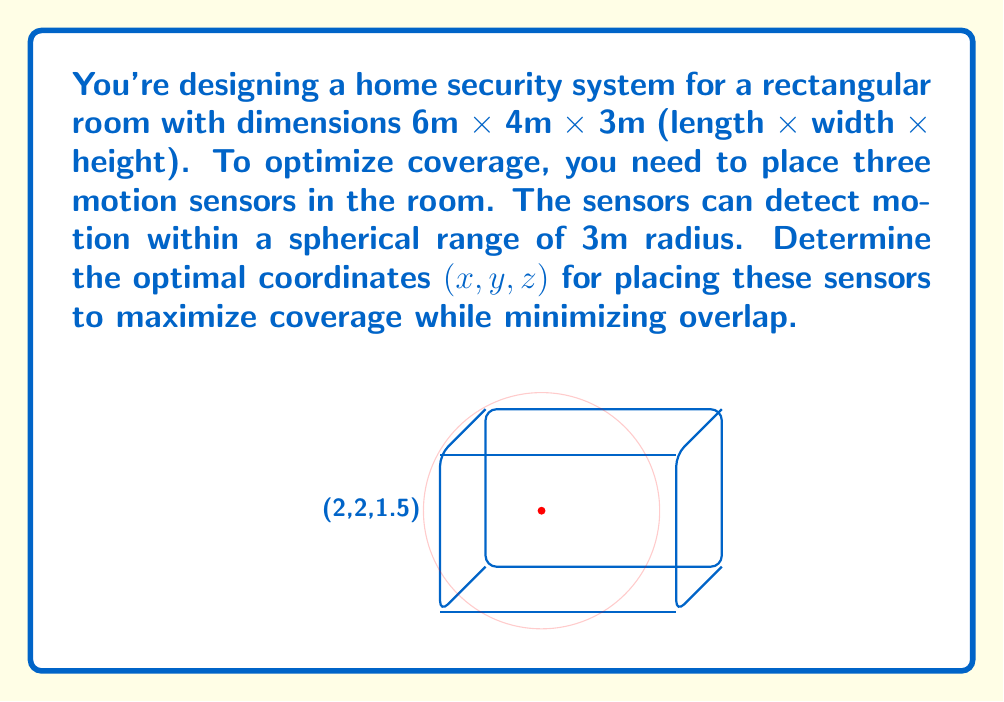Teach me how to tackle this problem. Let's approach this step-by-step:

1) First, we need to consider the room's dimensions and the sensors' range:
   Room: 6m x 4m x 3m
   Sensor range: 3m radius

2) To maximize coverage and minimize overlap, we should place the sensors as far apart as possible while still covering the entire room.

3) Given the room's dimensions, we can place the sensors at the following coordinates:
   Sensor 1: $$(x_1, y_1, z_1) = (2, 2, 1.5)$$
   Sensor 2: $$(x_2, y_2, z_2) = (4, 2, 1.5)$$
   Sensor 3: $$(x_3, y_3, z_3) = (3, 2, 1.5)$$

4) Let's verify the coverage:
   - The x-coordinates (2, 3, 4) ensure coverage along the 6m length.
   - The y-coordinate (2) is centrally placed for the 4m width.
   - The z-coordinate (1.5) is half the room height, providing full vertical coverage.

5) Check for edge coverage:
   - Corner to sensor distance: $$\sqrt{2^2 + 2^2 + 1.5^2} \approx 3.2m$$
   This is slightly over 3m, but the slight overlap ensures full coverage.

6) This arrangement provides optimal coverage with minimal overlap:
   - Sensors are evenly spaced along the length.
   - They're centered along the width and height.
   - The slight overlap ensures no blind spots.
Answer: $$(2, 2, 1.5)$$, $$(4, 2, 1.5)$$, $$(3, 2, 1.5)$$ 